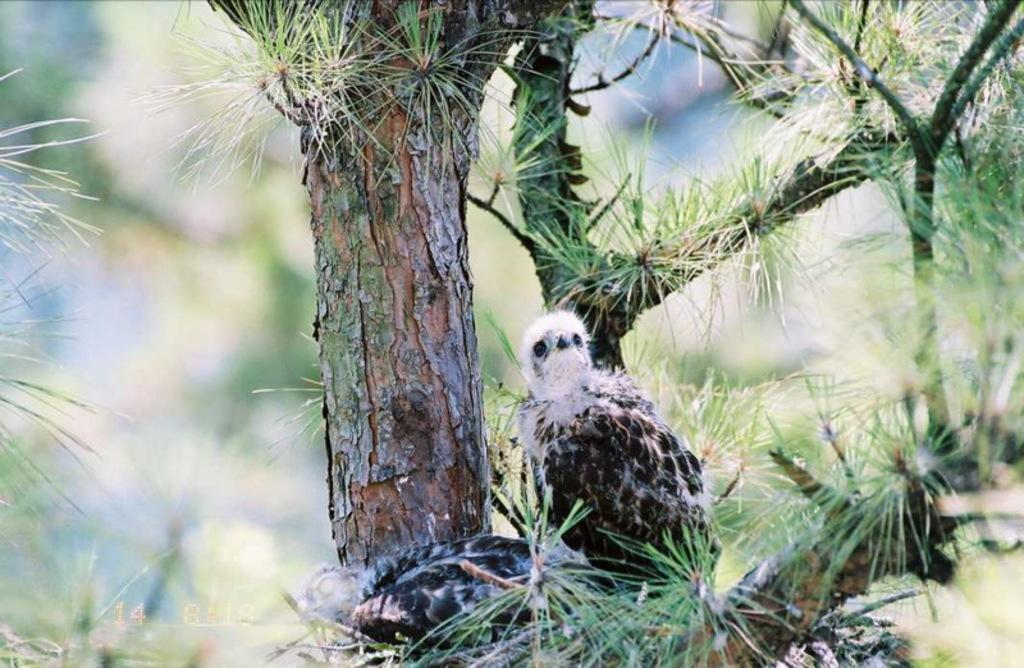What type of animal can be seen in the image? There is a bird in the image. Where is the bird located? The bird is standing on a branch of a tree. How is the background of the tree depicted in the image? The background of the tree is blurred. What type of event is the bird attending in the image? There is no indication of an event in the image; it simply shows a bird standing on a branch. 